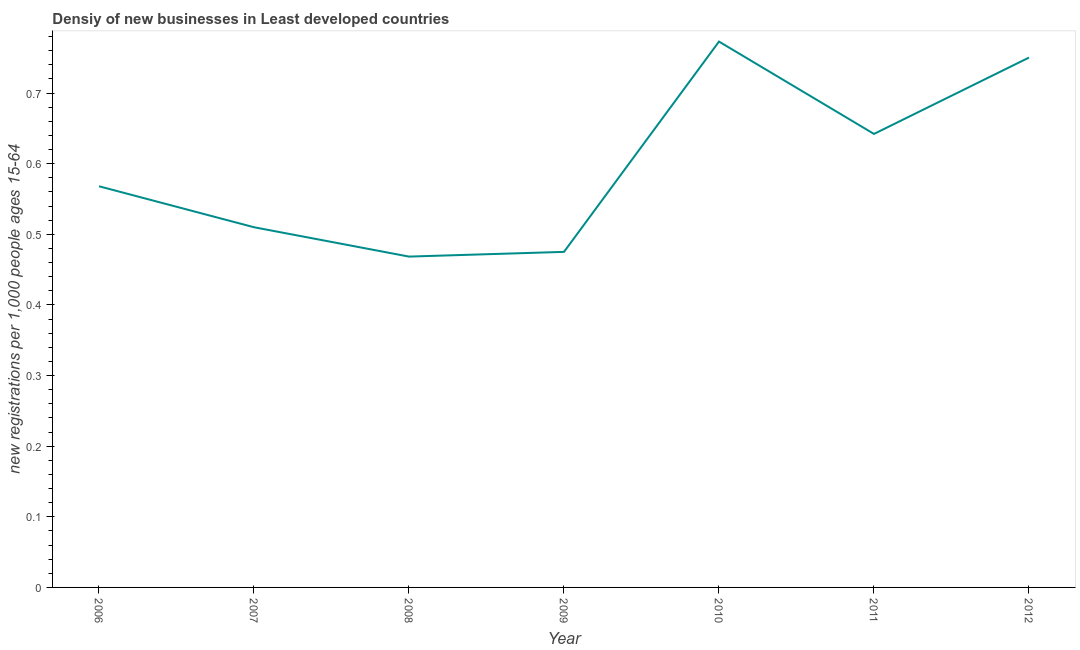What is the density of new business in 2007?
Give a very brief answer. 0.51. Across all years, what is the maximum density of new business?
Ensure brevity in your answer.  0.77. Across all years, what is the minimum density of new business?
Your response must be concise. 0.47. In which year was the density of new business maximum?
Make the answer very short. 2010. What is the sum of the density of new business?
Your answer should be compact. 4.19. What is the difference between the density of new business in 2006 and 2011?
Keep it short and to the point. -0.07. What is the average density of new business per year?
Make the answer very short. 0.6. What is the median density of new business?
Make the answer very short. 0.57. In how many years, is the density of new business greater than 0.12000000000000001 ?
Offer a very short reply. 7. Do a majority of the years between 2009 and 2010 (inclusive) have density of new business greater than 0.36000000000000004 ?
Provide a short and direct response. Yes. What is the ratio of the density of new business in 2010 to that in 2012?
Give a very brief answer. 1.03. Is the density of new business in 2006 less than that in 2008?
Provide a short and direct response. No. Is the difference between the density of new business in 2007 and 2008 greater than the difference between any two years?
Provide a succinct answer. No. What is the difference between the highest and the second highest density of new business?
Offer a terse response. 0.02. What is the difference between the highest and the lowest density of new business?
Give a very brief answer. 0.3. Does the density of new business monotonically increase over the years?
Offer a very short reply. No. How many lines are there?
Provide a short and direct response. 1. What is the difference between two consecutive major ticks on the Y-axis?
Provide a succinct answer. 0.1. Are the values on the major ticks of Y-axis written in scientific E-notation?
Offer a terse response. No. What is the title of the graph?
Give a very brief answer. Densiy of new businesses in Least developed countries. What is the label or title of the X-axis?
Offer a terse response. Year. What is the label or title of the Y-axis?
Ensure brevity in your answer.  New registrations per 1,0 people ages 15-64. What is the new registrations per 1,000 people ages 15-64 of 2006?
Ensure brevity in your answer.  0.57. What is the new registrations per 1,000 people ages 15-64 in 2007?
Your answer should be very brief. 0.51. What is the new registrations per 1,000 people ages 15-64 of 2008?
Make the answer very short. 0.47. What is the new registrations per 1,000 people ages 15-64 in 2009?
Provide a short and direct response. 0.48. What is the new registrations per 1,000 people ages 15-64 of 2010?
Make the answer very short. 0.77. What is the new registrations per 1,000 people ages 15-64 in 2011?
Keep it short and to the point. 0.64. What is the new registrations per 1,000 people ages 15-64 of 2012?
Your response must be concise. 0.75. What is the difference between the new registrations per 1,000 people ages 15-64 in 2006 and 2007?
Your answer should be very brief. 0.06. What is the difference between the new registrations per 1,000 people ages 15-64 in 2006 and 2008?
Offer a very short reply. 0.1. What is the difference between the new registrations per 1,000 people ages 15-64 in 2006 and 2009?
Offer a terse response. 0.09. What is the difference between the new registrations per 1,000 people ages 15-64 in 2006 and 2010?
Provide a short and direct response. -0.2. What is the difference between the new registrations per 1,000 people ages 15-64 in 2006 and 2011?
Keep it short and to the point. -0.07. What is the difference between the new registrations per 1,000 people ages 15-64 in 2006 and 2012?
Your answer should be compact. -0.18. What is the difference between the new registrations per 1,000 people ages 15-64 in 2007 and 2008?
Provide a succinct answer. 0.04. What is the difference between the new registrations per 1,000 people ages 15-64 in 2007 and 2009?
Offer a very short reply. 0.03. What is the difference between the new registrations per 1,000 people ages 15-64 in 2007 and 2010?
Your answer should be compact. -0.26. What is the difference between the new registrations per 1,000 people ages 15-64 in 2007 and 2011?
Keep it short and to the point. -0.13. What is the difference between the new registrations per 1,000 people ages 15-64 in 2007 and 2012?
Keep it short and to the point. -0.24. What is the difference between the new registrations per 1,000 people ages 15-64 in 2008 and 2009?
Keep it short and to the point. -0.01. What is the difference between the new registrations per 1,000 people ages 15-64 in 2008 and 2010?
Provide a short and direct response. -0.3. What is the difference between the new registrations per 1,000 people ages 15-64 in 2008 and 2011?
Provide a short and direct response. -0.17. What is the difference between the new registrations per 1,000 people ages 15-64 in 2008 and 2012?
Offer a terse response. -0.28. What is the difference between the new registrations per 1,000 people ages 15-64 in 2009 and 2010?
Provide a succinct answer. -0.3. What is the difference between the new registrations per 1,000 people ages 15-64 in 2009 and 2011?
Offer a terse response. -0.17. What is the difference between the new registrations per 1,000 people ages 15-64 in 2009 and 2012?
Provide a succinct answer. -0.28. What is the difference between the new registrations per 1,000 people ages 15-64 in 2010 and 2011?
Give a very brief answer. 0.13. What is the difference between the new registrations per 1,000 people ages 15-64 in 2010 and 2012?
Keep it short and to the point. 0.02. What is the difference between the new registrations per 1,000 people ages 15-64 in 2011 and 2012?
Your answer should be compact. -0.11. What is the ratio of the new registrations per 1,000 people ages 15-64 in 2006 to that in 2007?
Offer a very short reply. 1.11. What is the ratio of the new registrations per 1,000 people ages 15-64 in 2006 to that in 2008?
Keep it short and to the point. 1.21. What is the ratio of the new registrations per 1,000 people ages 15-64 in 2006 to that in 2009?
Make the answer very short. 1.2. What is the ratio of the new registrations per 1,000 people ages 15-64 in 2006 to that in 2010?
Provide a succinct answer. 0.73. What is the ratio of the new registrations per 1,000 people ages 15-64 in 2006 to that in 2011?
Keep it short and to the point. 0.89. What is the ratio of the new registrations per 1,000 people ages 15-64 in 2006 to that in 2012?
Provide a succinct answer. 0.76. What is the ratio of the new registrations per 1,000 people ages 15-64 in 2007 to that in 2008?
Your answer should be very brief. 1.09. What is the ratio of the new registrations per 1,000 people ages 15-64 in 2007 to that in 2009?
Ensure brevity in your answer.  1.07. What is the ratio of the new registrations per 1,000 people ages 15-64 in 2007 to that in 2010?
Offer a terse response. 0.66. What is the ratio of the new registrations per 1,000 people ages 15-64 in 2007 to that in 2011?
Provide a short and direct response. 0.79. What is the ratio of the new registrations per 1,000 people ages 15-64 in 2007 to that in 2012?
Offer a very short reply. 0.68. What is the ratio of the new registrations per 1,000 people ages 15-64 in 2008 to that in 2009?
Provide a short and direct response. 0.99. What is the ratio of the new registrations per 1,000 people ages 15-64 in 2008 to that in 2010?
Provide a short and direct response. 0.61. What is the ratio of the new registrations per 1,000 people ages 15-64 in 2008 to that in 2011?
Your response must be concise. 0.73. What is the ratio of the new registrations per 1,000 people ages 15-64 in 2008 to that in 2012?
Your response must be concise. 0.62. What is the ratio of the new registrations per 1,000 people ages 15-64 in 2009 to that in 2010?
Your answer should be compact. 0.61. What is the ratio of the new registrations per 1,000 people ages 15-64 in 2009 to that in 2011?
Make the answer very short. 0.74. What is the ratio of the new registrations per 1,000 people ages 15-64 in 2009 to that in 2012?
Provide a succinct answer. 0.63. What is the ratio of the new registrations per 1,000 people ages 15-64 in 2010 to that in 2011?
Your answer should be very brief. 1.2. What is the ratio of the new registrations per 1,000 people ages 15-64 in 2011 to that in 2012?
Offer a terse response. 0.86. 